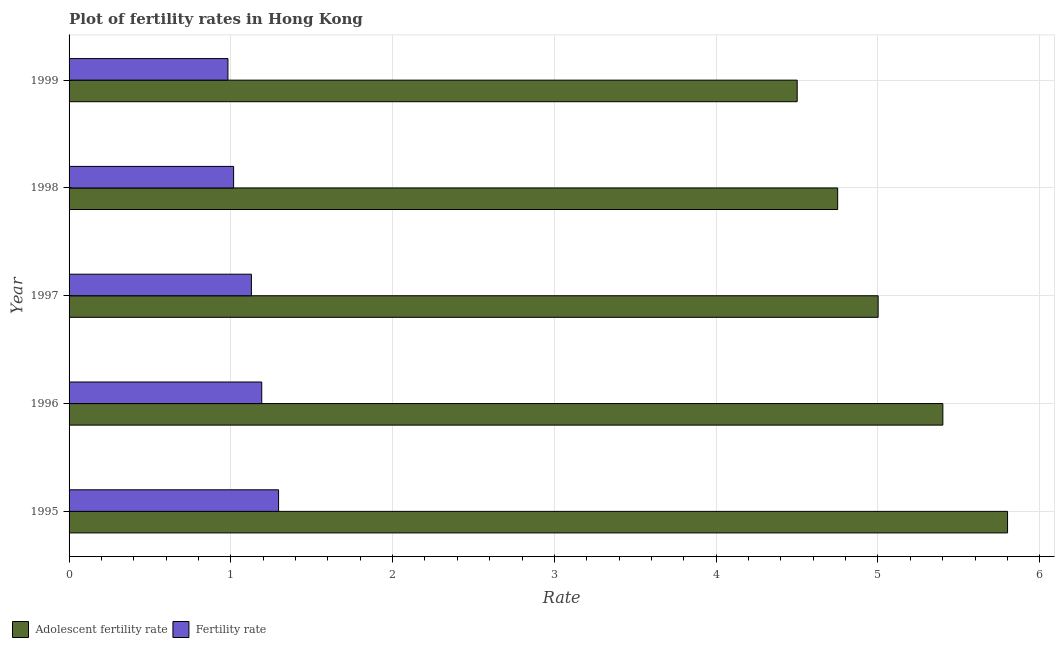How many different coloured bars are there?
Provide a succinct answer. 2. How many groups of bars are there?
Make the answer very short. 5. Are the number of bars per tick equal to the number of legend labels?
Give a very brief answer. Yes. Are the number of bars on each tick of the Y-axis equal?
Offer a very short reply. Yes. How many bars are there on the 1st tick from the top?
Provide a short and direct response. 2. What is the label of the 4th group of bars from the top?
Give a very brief answer. 1996. What is the fertility rate in 1995?
Your answer should be compact. 1.29. Across all years, what is the maximum fertility rate?
Your answer should be compact. 1.29. In which year was the adolescent fertility rate maximum?
Give a very brief answer. 1995. In which year was the adolescent fertility rate minimum?
Provide a succinct answer. 1999. What is the total adolescent fertility rate in the graph?
Provide a short and direct response. 25.45. What is the difference between the adolescent fertility rate in 1997 and that in 1998?
Offer a very short reply. 0.25. What is the difference between the fertility rate in 1998 and the adolescent fertility rate in 1996?
Offer a very short reply. -4.38. What is the average fertility rate per year?
Your answer should be compact. 1.12. In the year 1997, what is the difference between the fertility rate and adolescent fertility rate?
Provide a short and direct response. -3.87. What is the ratio of the adolescent fertility rate in 1995 to that in 1998?
Offer a very short reply. 1.22. Is the fertility rate in 1995 less than that in 1997?
Your response must be concise. No. Is the difference between the adolescent fertility rate in 1995 and 1998 greater than the difference between the fertility rate in 1995 and 1998?
Give a very brief answer. Yes. What is the difference between the highest and the second highest fertility rate?
Make the answer very short. 0.1. What is the difference between the highest and the lowest fertility rate?
Make the answer very short. 0.31. Is the sum of the adolescent fertility rate in 1997 and 1998 greater than the maximum fertility rate across all years?
Provide a short and direct response. Yes. What does the 2nd bar from the top in 1995 represents?
Your answer should be very brief. Adolescent fertility rate. What does the 2nd bar from the bottom in 1995 represents?
Offer a very short reply. Fertility rate. How many bars are there?
Provide a short and direct response. 10. Are all the bars in the graph horizontal?
Your response must be concise. Yes. What is the difference between two consecutive major ticks on the X-axis?
Make the answer very short. 1. Are the values on the major ticks of X-axis written in scientific E-notation?
Your response must be concise. No. How many legend labels are there?
Keep it short and to the point. 2. What is the title of the graph?
Ensure brevity in your answer.  Plot of fertility rates in Hong Kong. What is the label or title of the X-axis?
Ensure brevity in your answer.  Rate. What is the Rate in Adolescent fertility rate in 1995?
Your response must be concise. 5.8. What is the Rate in Fertility rate in 1995?
Your answer should be compact. 1.29. What is the Rate in Adolescent fertility rate in 1996?
Ensure brevity in your answer.  5.4. What is the Rate of Fertility rate in 1996?
Your response must be concise. 1.19. What is the Rate of Adolescent fertility rate in 1997?
Provide a succinct answer. 5. What is the Rate in Fertility rate in 1997?
Your answer should be very brief. 1.13. What is the Rate in Adolescent fertility rate in 1998?
Your answer should be compact. 4.75. What is the Rate of Adolescent fertility rate in 1999?
Give a very brief answer. 4.5. Across all years, what is the maximum Rate in Adolescent fertility rate?
Keep it short and to the point. 5.8. Across all years, what is the maximum Rate of Fertility rate?
Provide a short and direct response. 1.29. Across all years, what is the minimum Rate in Adolescent fertility rate?
Provide a short and direct response. 4.5. Across all years, what is the minimum Rate of Fertility rate?
Make the answer very short. 0.98. What is the total Rate of Adolescent fertility rate in the graph?
Offer a very short reply. 25.45. What is the total Rate in Fertility rate in the graph?
Offer a terse response. 5.61. What is the difference between the Rate of Fertility rate in 1995 and that in 1996?
Your response must be concise. 0.1. What is the difference between the Rate in Adolescent fertility rate in 1995 and that in 1997?
Offer a terse response. 0.8. What is the difference between the Rate in Fertility rate in 1995 and that in 1997?
Keep it short and to the point. 0.17. What is the difference between the Rate in Adolescent fertility rate in 1995 and that in 1998?
Offer a very short reply. 1.05. What is the difference between the Rate in Fertility rate in 1995 and that in 1998?
Your answer should be very brief. 0.28. What is the difference between the Rate of Adolescent fertility rate in 1995 and that in 1999?
Provide a short and direct response. 1.3. What is the difference between the Rate in Fertility rate in 1995 and that in 1999?
Your answer should be compact. 0.31. What is the difference between the Rate in Adolescent fertility rate in 1996 and that in 1997?
Your response must be concise. 0.4. What is the difference between the Rate of Fertility rate in 1996 and that in 1997?
Provide a short and direct response. 0.06. What is the difference between the Rate of Adolescent fertility rate in 1996 and that in 1998?
Keep it short and to the point. 0.65. What is the difference between the Rate of Fertility rate in 1996 and that in 1998?
Your answer should be compact. 0.17. What is the difference between the Rate in Adolescent fertility rate in 1996 and that in 1999?
Your response must be concise. 0.9. What is the difference between the Rate of Fertility rate in 1996 and that in 1999?
Give a very brief answer. 0.21. What is the difference between the Rate of Adolescent fertility rate in 1997 and that in 1998?
Provide a short and direct response. 0.25. What is the difference between the Rate of Fertility rate in 1997 and that in 1998?
Provide a short and direct response. 0.11. What is the difference between the Rate in Adolescent fertility rate in 1997 and that in 1999?
Offer a terse response. 0.5. What is the difference between the Rate of Fertility rate in 1997 and that in 1999?
Give a very brief answer. 0.14. What is the difference between the Rate of Adolescent fertility rate in 1998 and that in 1999?
Your answer should be very brief. 0.25. What is the difference between the Rate in Fertility rate in 1998 and that in 1999?
Give a very brief answer. 0.04. What is the difference between the Rate of Adolescent fertility rate in 1995 and the Rate of Fertility rate in 1996?
Offer a very short reply. 4.61. What is the difference between the Rate of Adolescent fertility rate in 1995 and the Rate of Fertility rate in 1997?
Ensure brevity in your answer.  4.67. What is the difference between the Rate of Adolescent fertility rate in 1995 and the Rate of Fertility rate in 1998?
Give a very brief answer. 4.78. What is the difference between the Rate in Adolescent fertility rate in 1995 and the Rate in Fertility rate in 1999?
Offer a very short reply. 4.82. What is the difference between the Rate in Adolescent fertility rate in 1996 and the Rate in Fertility rate in 1997?
Your answer should be very brief. 4.27. What is the difference between the Rate of Adolescent fertility rate in 1996 and the Rate of Fertility rate in 1998?
Provide a succinct answer. 4.38. What is the difference between the Rate of Adolescent fertility rate in 1996 and the Rate of Fertility rate in 1999?
Ensure brevity in your answer.  4.42. What is the difference between the Rate of Adolescent fertility rate in 1997 and the Rate of Fertility rate in 1998?
Offer a terse response. 3.98. What is the difference between the Rate in Adolescent fertility rate in 1997 and the Rate in Fertility rate in 1999?
Your response must be concise. 4.02. What is the difference between the Rate in Adolescent fertility rate in 1998 and the Rate in Fertility rate in 1999?
Provide a succinct answer. 3.77. What is the average Rate in Adolescent fertility rate per year?
Your answer should be very brief. 5.09. What is the average Rate of Fertility rate per year?
Provide a succinct answer. 1.12. In the year 1995, what is the difference between the Rate in Adolescent fertility rate and Rate in Fertility rate?
Give a very brief answer. 4.51. In the year 1996, what is the difference between the Rate in Adolescent fertility rate and Rate in Fertility rate?
Your answer should be compact. 4.21. In the year 1997, what is the difference between the Rate of Adolescent fertility rate and Rate of Fertility rate?
Provide a succinct answer. 3.87. In the year 1998, what is the difference between the Rate in Adolescent fertility rate and Rate in Fertility rate?
Your response must be concise. 3.73. In the year 1999, what is the difference between the Rate of Adolescent fertility rate and Rate of Fertility rate?
Make the answer very short. 3.52. What is the ratio of the Rate in Adolescent fertility rate in 1995 to that in 1996?
Your answer should be compact. 1.07. What is the ratio of the Rate in Fertility rate in 1995 to that in 1996?
Your response must be concise. 1.09. What is the ratio of the Rate in Adolescent fertility rate in 1995 to that in 1997?
Offer a terse response. 1.16. What is the ratio of the Rate of Fertility rate in 1995 to that in 1997?
Provide a succinct answer. 1.15. What is the ratio of the Rate in Adolescent fertility rate in 1995 to that in 1998?
Ensure brevity in your answer.  1.22. What is the ratio of the Rate of Fertility rate in 1995 to that in 1998?
Keep it short and to the point. 1.27. What is the ratio of the Rate of Adolescent fertility rate in 1995 to that in 1999?
Your response must be concise. 1.29. What is the ratio of the Rate in Fertility rate in 1995 to that in 1999?
Ensure brevity in your answer.  1.32. What is the ratio of the Rate in Adolescent fertility rate in 1996 to that in 1997?
Your response must be concise. 1.08. What is the ratio of the Rate of Fertility rate in 1996 to that in 1997?
Provide a short and direct response. 1.06. What is the ratio of the Rate of Adolescent fertility rate in 1996 to that in 1998?
Ensure brevity in your answer.  1.14. What is the ratio of the Rate of Fertility rate in 1996 to that in 1998?
Make the answer very short. 1.17. What is the ratio of the Rate in Adolescent fertility rate in 1996 to that in 1999?
Keep it short and to the point. 1.2. What is the ratio of the Rate in Fertility rate in 1996 to that in 1999?
Provide a short and direct response. 1.21. What is the ratio of the Rate of Adolescent fertility rate in 1997 to that in 1998?
Offer a terse response. 1.05. What is the ratio of the Rate of Fertility rate in 1997 to that in 1998?
Your response must be concise. 1.11. What is the ratio of the Rate in Adolescent fertility rate in 1997 to that in 1999?
Provide a short and direct response. 1.11. What is the ratio of the Rate in Fertility rate in 1997 to that in 1999?
Ensure brevity in your answer.  1.15. What is the ratio of the Rate in Adolescent fertility rate in 1998 to that in 1999?
Make the answer very short. 1.06. What is the ratio of the Rate in Fertility rate in 1998 to that in 1999?
Provide a short and direct response. 1.04. What is the difference between the highest and the second highest Rate of Fertility rate?
Offer a terse response. 0.1. What is the difference between the highest and the lowest Rate of Adolescent fertility rate?
Your response must be concise. 1.3. What is the difference between the highest and the lowest Rate in Fertility rate?
Your answer should be very brief. 0.31. 